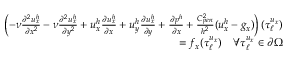Convert formula to latex. <formula><loc_0><loc_0><loc_500><loc_500>\begin{array} { r } { \left ( - \nu \frac { \partial ^ { 2 } u _ { x } ^ { h } } { \partial x ^ { 2 } } - \nu \frac { \partial ^ { 2 } u _ { x } ^ { h } } { \partial y ^ { 2 } } + u _ { x } ^ { h } \frac { \partial u _ { x } ^ { h } } { \partial x } + u _ { y } ^ { h } \frac { \partial u _ { x } ^ { h } } { \partial y } + \frac { \partial p ^ { h } } { \partial x } + \frac { C _ { p e n } ^ { 2 } } { h ^ { 2 } } ( u _ { x } ^ { h } - g _ { x } ) \right ) ( \tau _ { \ell } ^ { u _ { x } } ) } \\ { = f _ { x } ( \tau _ { \ell } ^ { u _ { x } } ) \quad \forall \tau _ { \ell } ^ { u _ { x } } \in \partial \Omega } \end{array}</formula> 